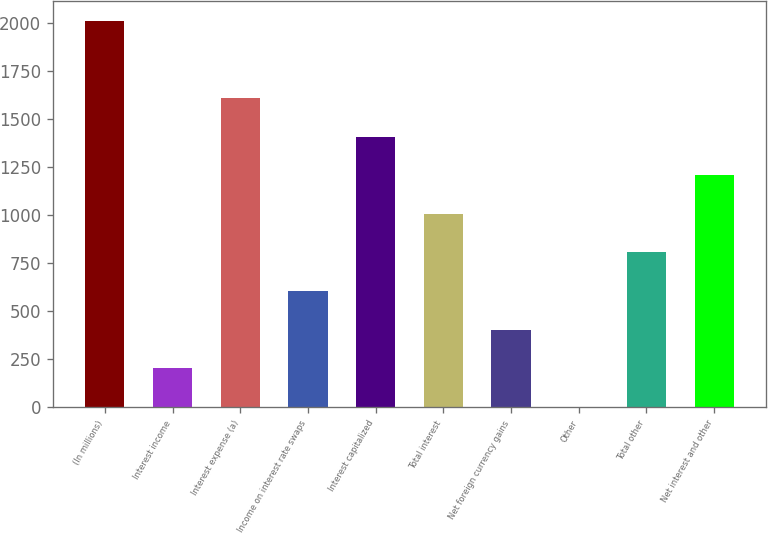<chart> <loc_0><loc_0><loc_500><loc_500><bar_chart><fcel>(In millions)<fcel>Interest income<fcel>Interest expense (a)<fcel>Income on interest rate swaps<fcel>Interest capitalized<fcel>Total interest<fcel>Net foreign currency gains<fcel>Other<fcel>Total other<fcel>Net interest and other<nl><fcel>2010<fcel>202.8<fcel>1608.4<fcel>604.4<fcel>1407.6<fcel>1006<fcel>403.6<fcel>2<fcel>805.2<fcel>1206.8<nl></chart> 